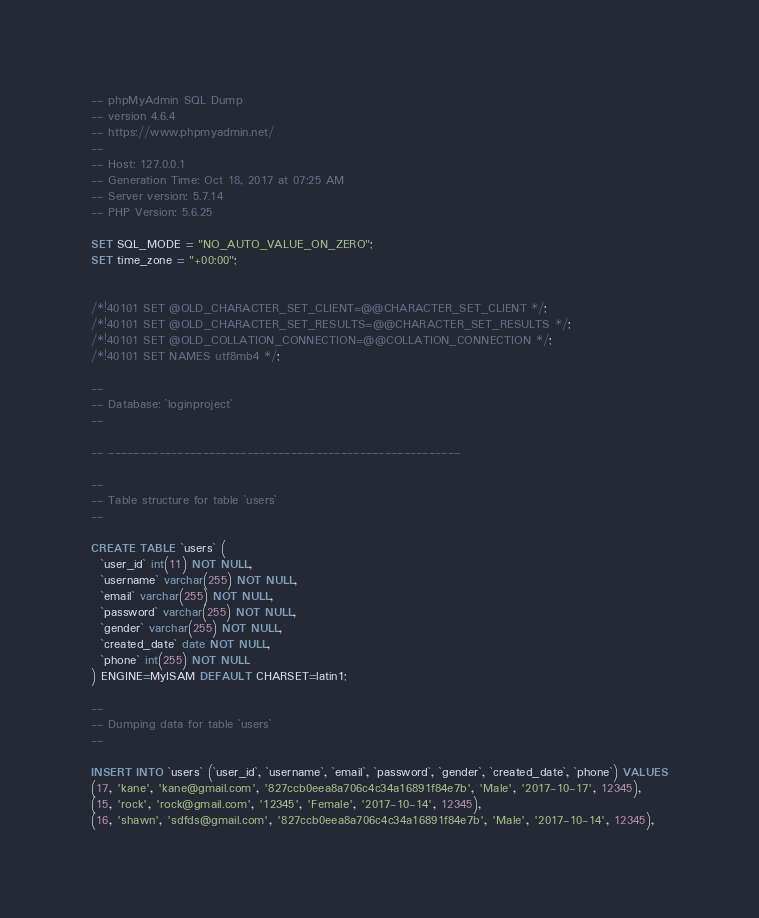<code> <loc_0><loc_0><loc_500><loc_500><_SQL_>-- phpMyAdmin SQL Dump
-- version 4.6.4
-- https://www.phpmyadmin.net/
--
-- Host: 127.0.0.1
-- Generation Time: Oct 18, 2017 at 07:25 AM
-- Server version: 5.7.14
-- PHP Version: 5.6.25

SET SQL_MODE = "NO_AUTO_VALUE_ON_ZERO";
SET time_zone = "+00:00";


/*!40101 SET @OLD_CHARACTER_SET_CLIENT=@@CHARACTER_SET_CLIENT */;
/*!40101 SET @OLD_CHARACTER_SET_RESULTS=@@CHARACTER_SET_RESULTS */;
/*!40101 SET @OLD_COLLATION_CONNECTION=@@COLLATION_CONNECTION */;
/*!40101 SET NAMES utf8mb4 */;

--
-- Database: `loginproject`
--

-- --------------------------------------------------------

--
-- Table structure for table `users`
--

CREATE TABLE `users` (
  `user_id` int(11) NOT NULL,
  `username` varchar(255) NOT NULL,
  `email` varchar(255) NOT NULL,
  `password` varchar(255) NOT NULL,
  `gender` varchar(255) NOT NULL,
  `created_date` date NOT NULL,
  `phone` int(255) NOT NULL
) ENGINE=MyISAM DEFAULT CHARSET=latin1;

--
-- Dumping data for table `users`
--

INSERT INTO `users` (`user_id`, `username`, `email`, `password`, `gender`, `created_date`, `phone`) VALUES
(17, 'kane', 'kane@gmail.com', '827ccb0eea8a706c4c34a16891f84e7b', 'Male', '2017-10-17', 12345),
(15, 'rock', 'rock@gmail.com', '12345', 'Female', '2017-10-14', 12345),
(16, 'shawn', 'sdfds@gmail.com', '827ccb0eea8a706c4c34a16891f84e7b', 'Male', '2017-10-14', 12345),</code> 